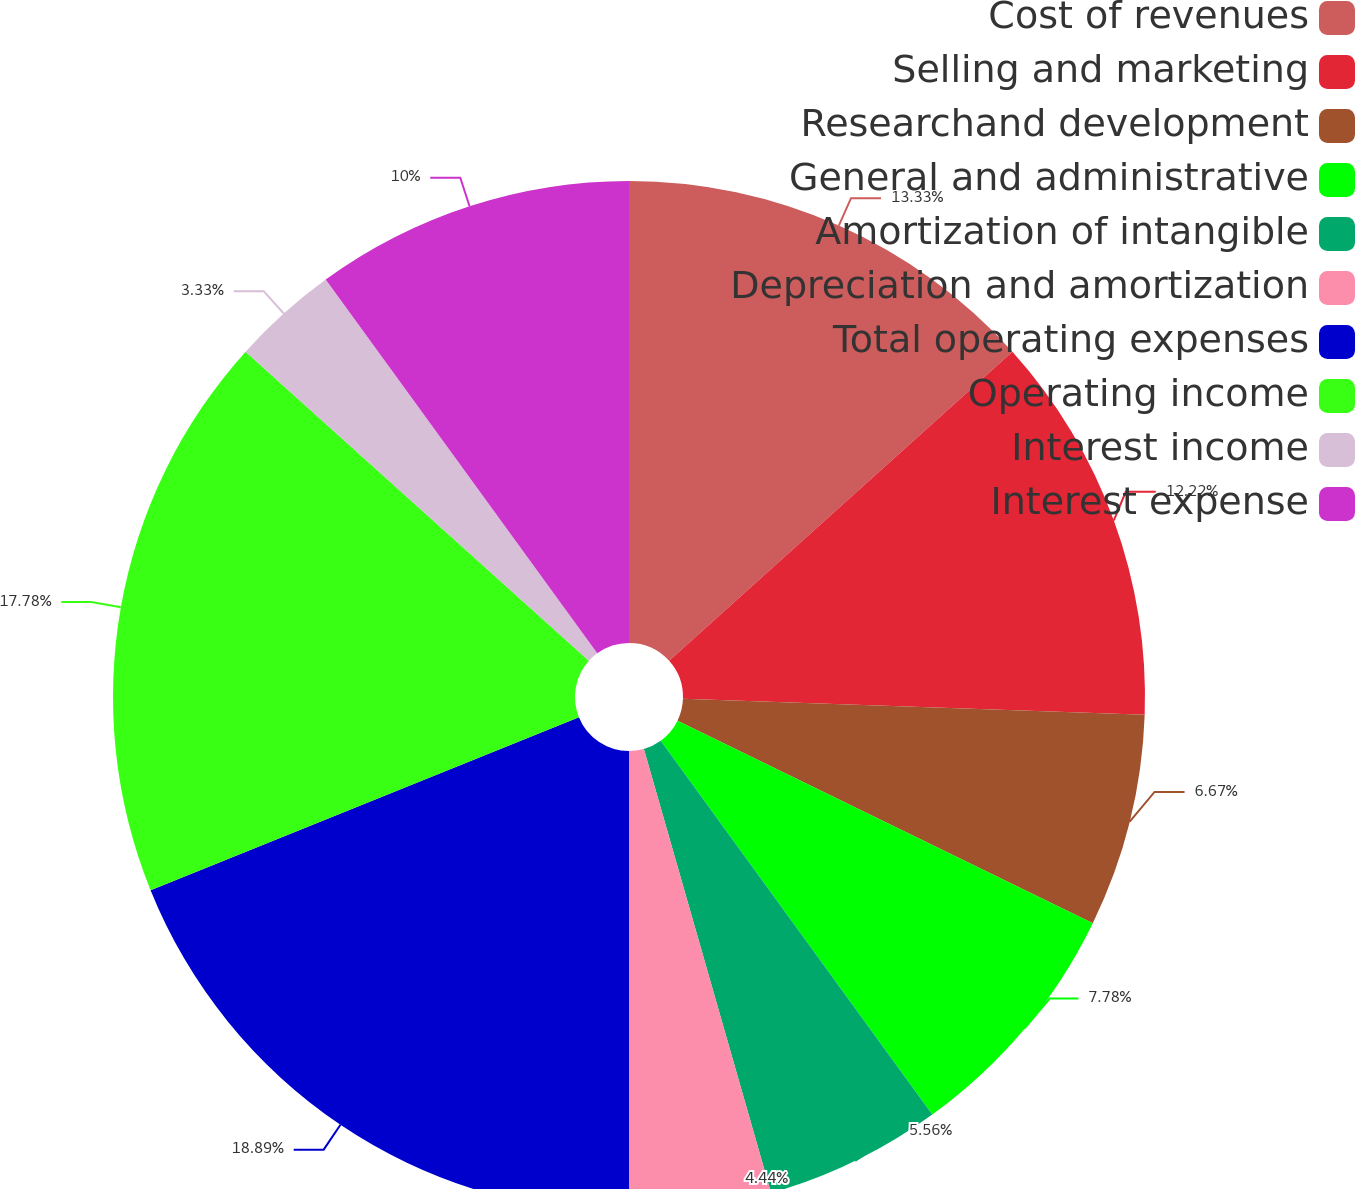Convert chart. <chart><loc_0><loc_0><loc_500><loc_500><pie_chart><fcel>Cost of revenues<fcel>Selling and marketing<fcel>Researchand development<fcel>General and administrative<fcel>Amortization of intangible<fcel>Depreciation and amortization<fcel>Total operating expenses<fcel>Operating income<fcel>Interest income<fcel>Interest expense<nl><fcel>13.33%<fcel>12.22%<fcel>6.67%<fcel>7.78%<fcel>5.56%<fcel>4.44%<fcel>18.89%<fcel>17.78%<fcel>3.33%<fcel>10.0%<nl></chart> 